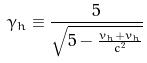Convert formula to latex. <formula><loc_0><loc_0><loc_500><loc_500>\gamma _ { h } \equiv \frac { 5 } { \sqrt { 5 - \frac { v _ { h } + v _ { h } } { c ^ { 2 } } } }</formula> 